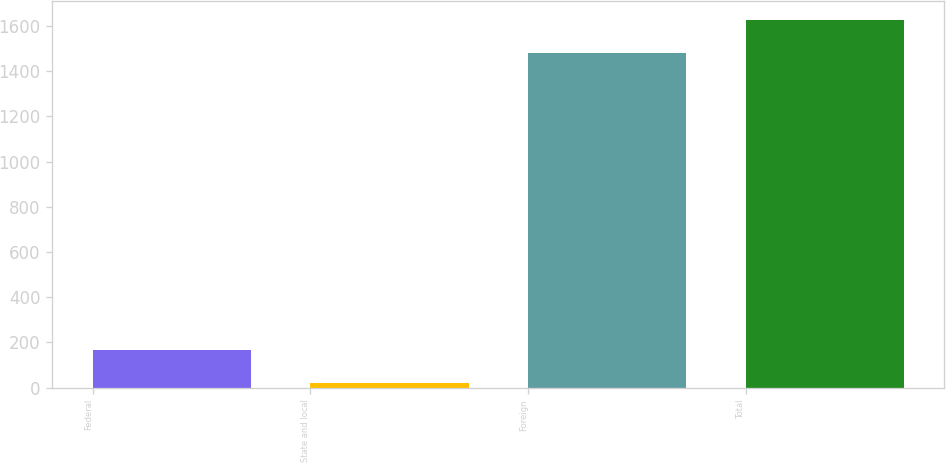Convert chart to OTSL. <chart><loc_0><loc_0><loc_500><loc_500><bar_chart><fcel>Federal<fcel>State and local<fcel>Foreign<fcel>Total<nl><fcel>167.2<fcel>19<fcel>1480<fcel>1628.2<nl></chart> 